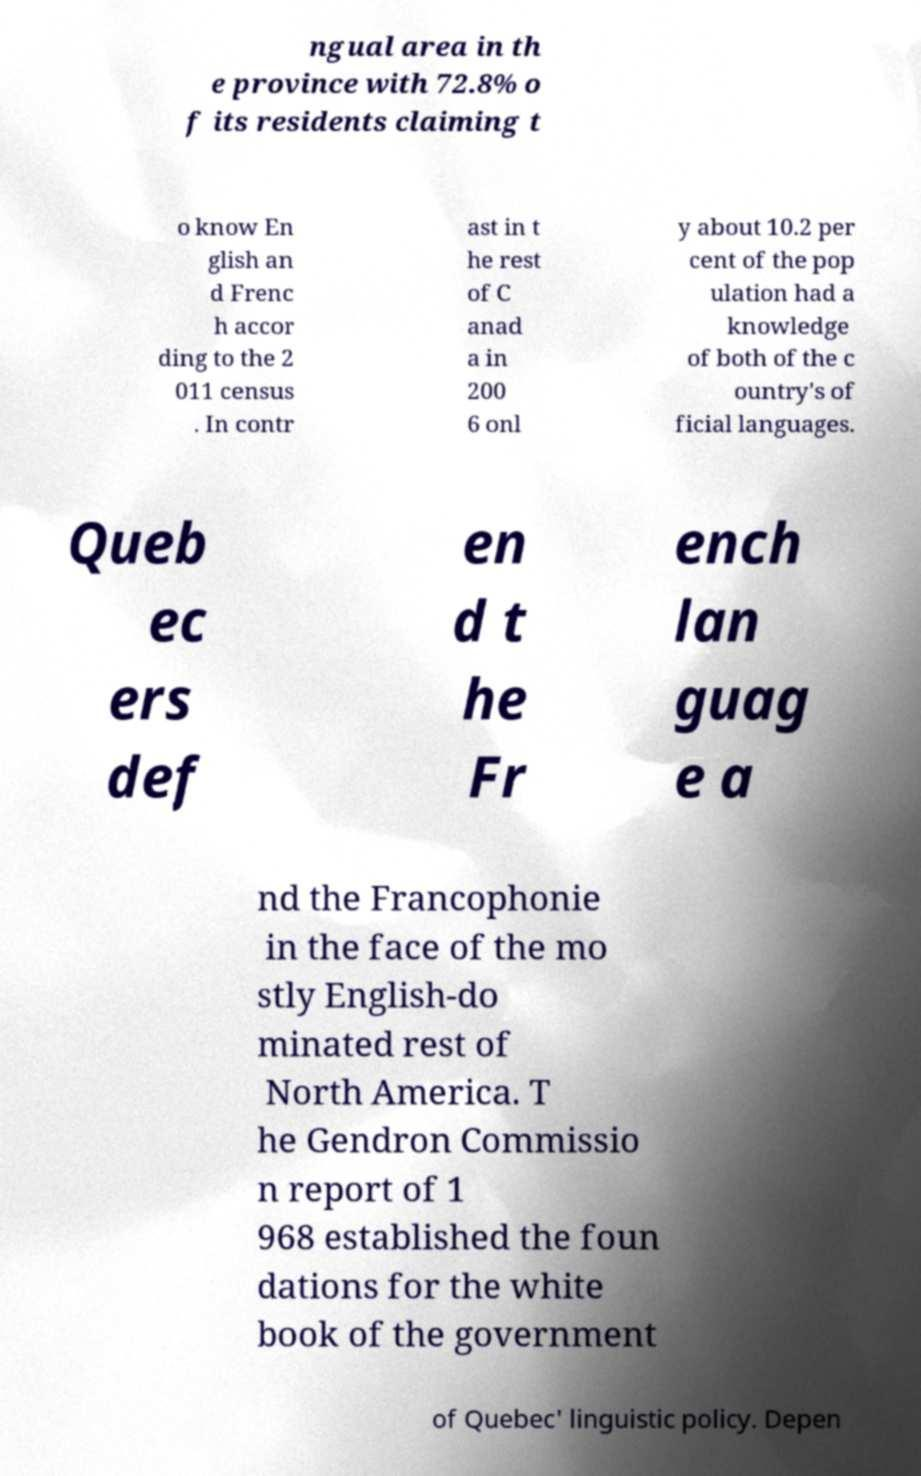Can you read and provide the text displayed in the image?This photo seems to have some interesting text. Can you extract and type it out for me? ngual area in th e province with 72.8% o f its residents claiming t o know En glish an d Frenc h accor ding to the 2 011 census . In contr ast in t he rest of C anad a in 200 6 onl y about 10.2 per cent of the pop ulation had a knowledge of both of the c ountry's of ficial languages. Queb ec ers def en d t he Fr ench lan guag e a nd the Francophonie in the face of the mo stly English-do minated rest of North America. T he Gendron Commissio n report of 1 968 established the foun dations for the white book of the government of Quebec' linguistic policy. Depen 